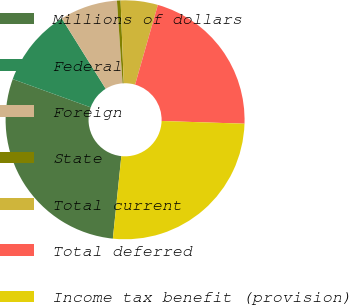Convert chart to OTSL. <chart><loc_0><loc_0><loc_500><loc_500><pie_chart><fcel>Millions of dollars<fcel>Federal<fcel>Foreign<fcel>State<fcel>Total current<fcel>Total deferred<fcel>Income tax benefit (provision)<nl><fcel>28.9%<fcel>10.59%<fcel>7.8%<fcel>0.49%<fcel>5.02%<fcel>21.1%<fcel>26.11%<nl></chart> 